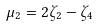<formula> <loc_0><loc_0><loc_500><loc_500>\mu _ { 2 } = 2 \zeta _ { 2 } - \zeta _ { 4 }</formula> 